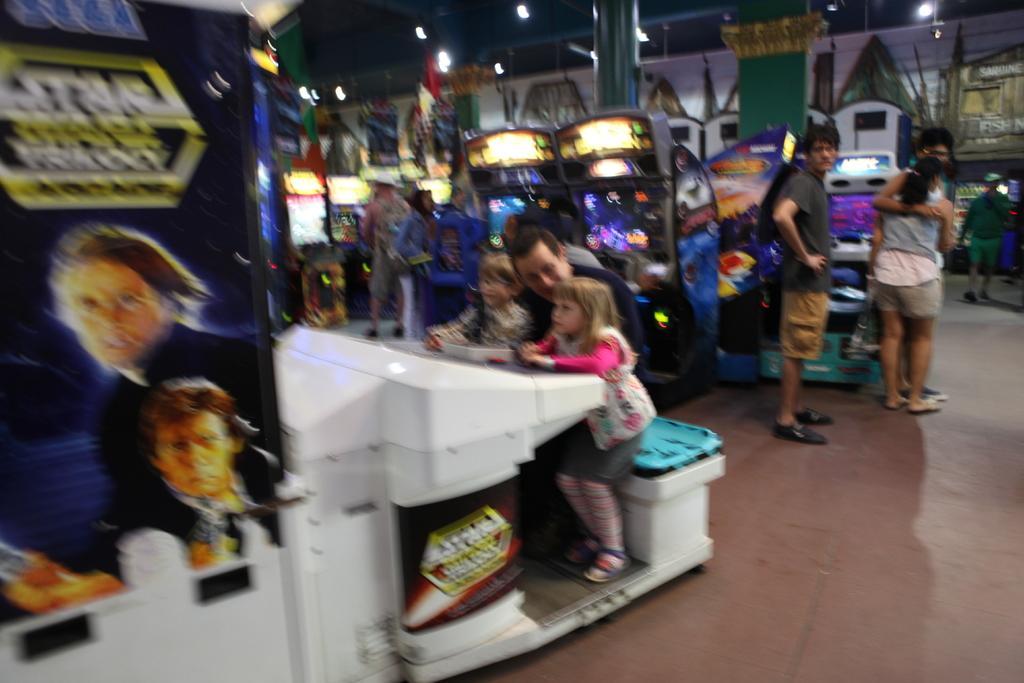Please provide a concise description of this image. This image is taken inside the gaming zone. In this image we can see people with kids. Image also consists of play stations and also lights. On the left we can see a hoarding. Floor is also visible. 